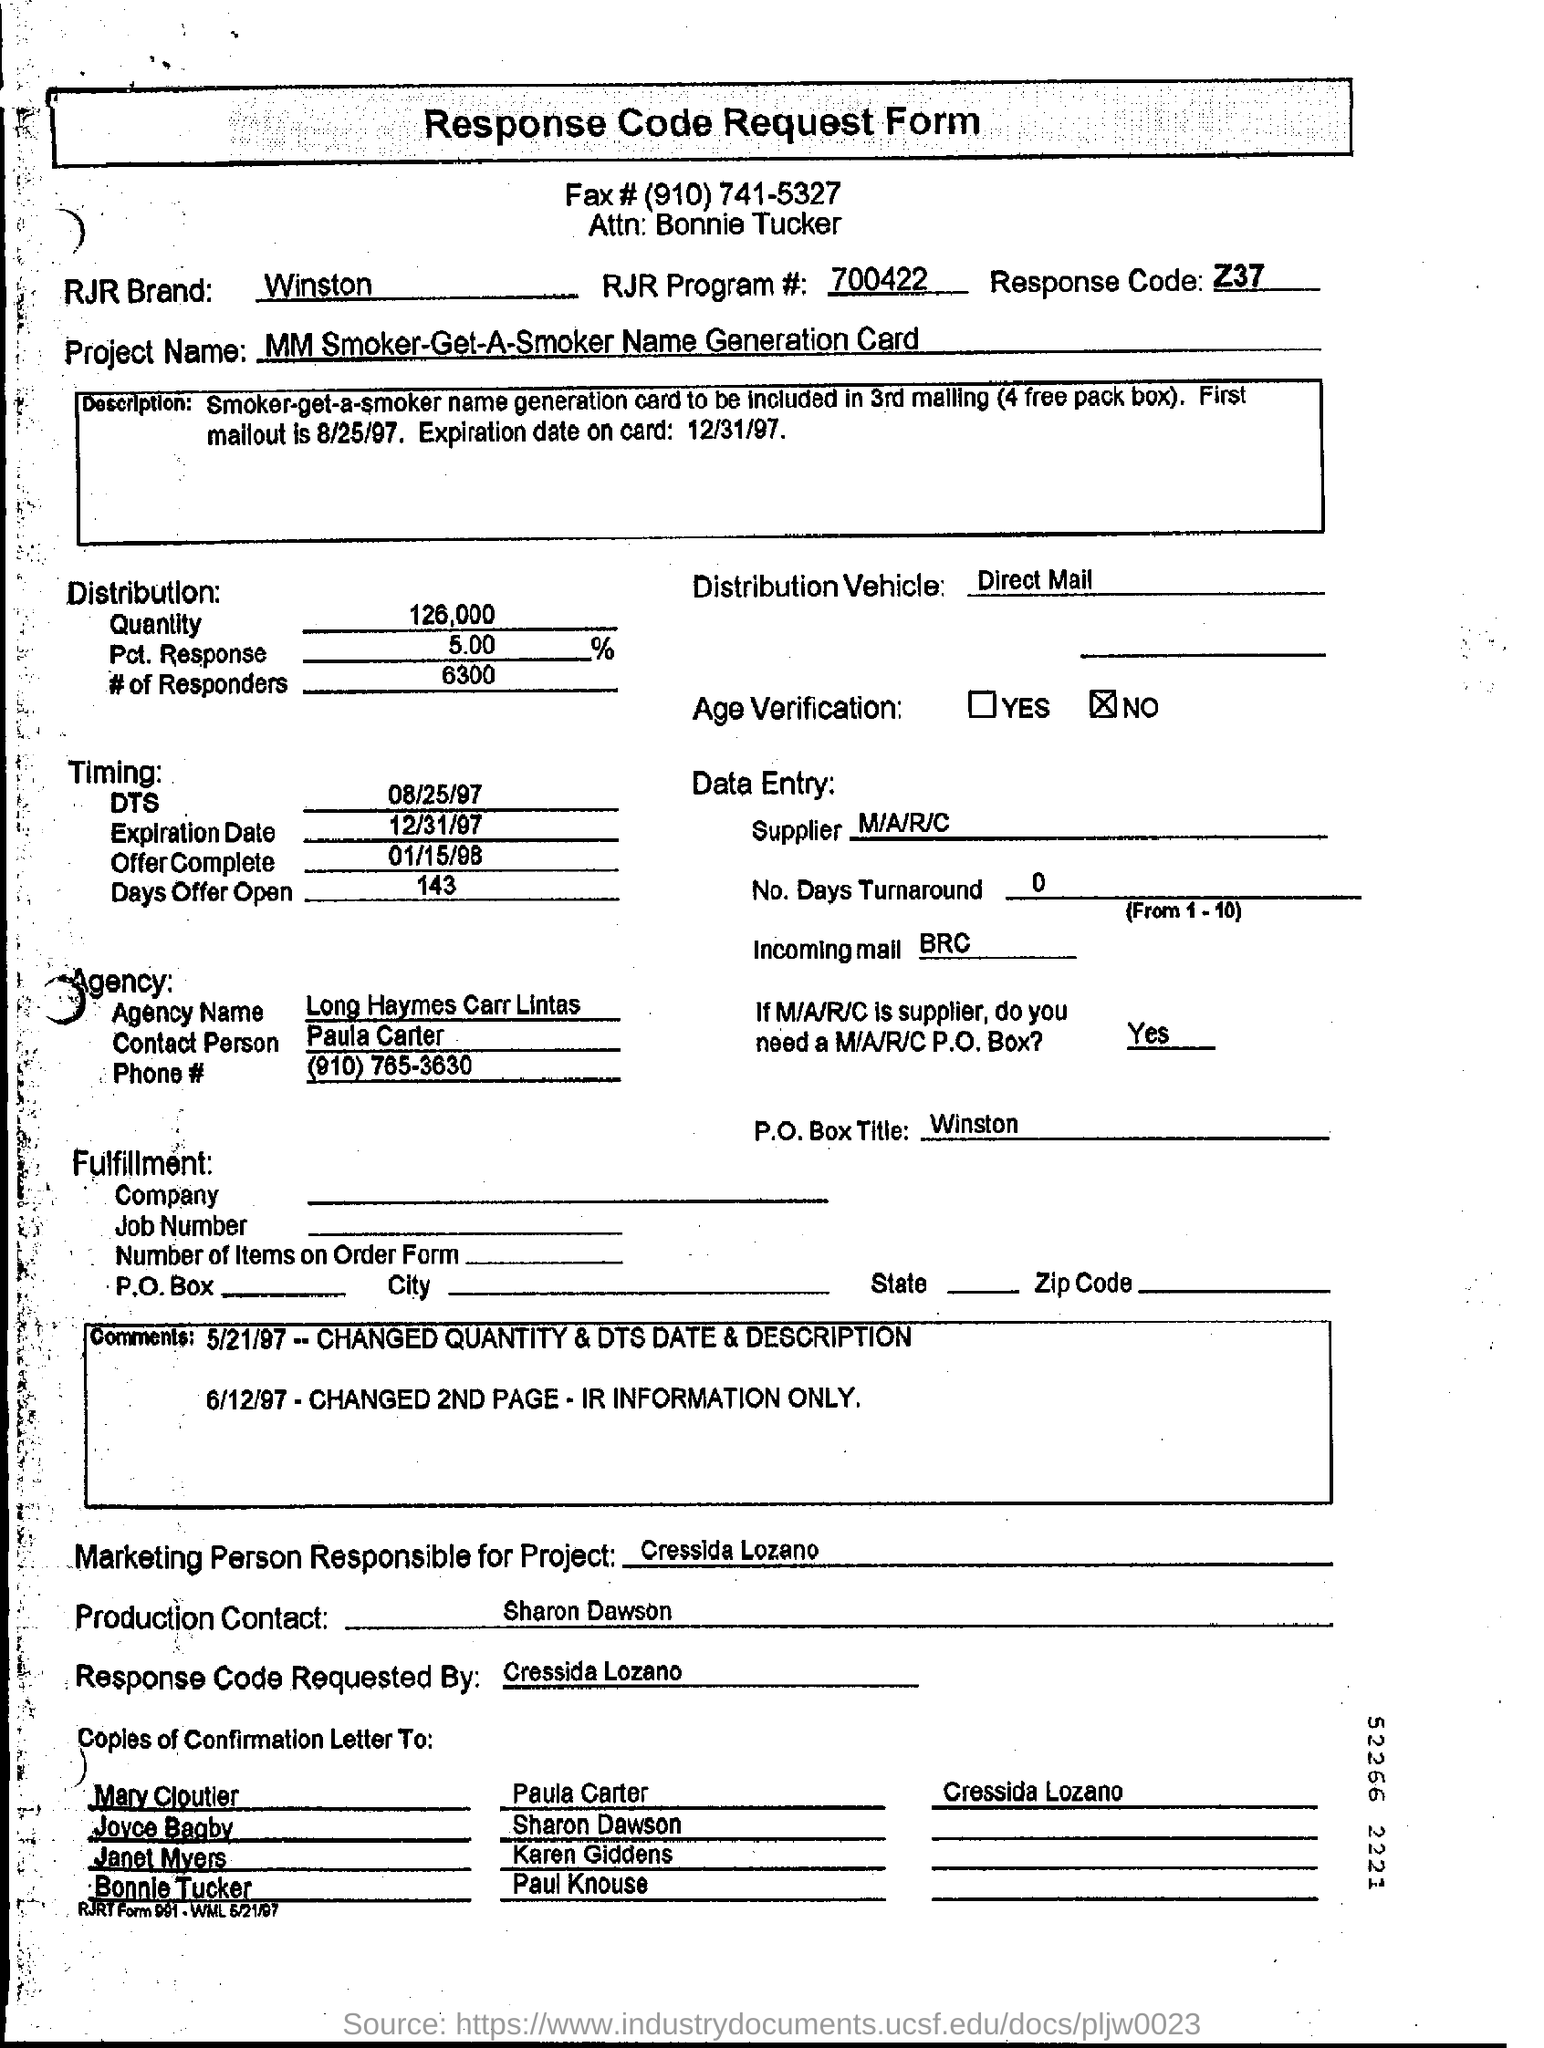What is the RJR Brand mentioned on the response code request form?
Offer a very short reply. Winston. What is the RJR program number mentioned on the response code request form?
Offer a very short reply. 700422. What is the response code mentioned in the form?
Provide a succinct answer. Z37. For how days is the offer open?
Ensure brevity in your answer.  143. Who requested the response code request form?
Ensure brevity in your answer.  Cressida Lozano. 